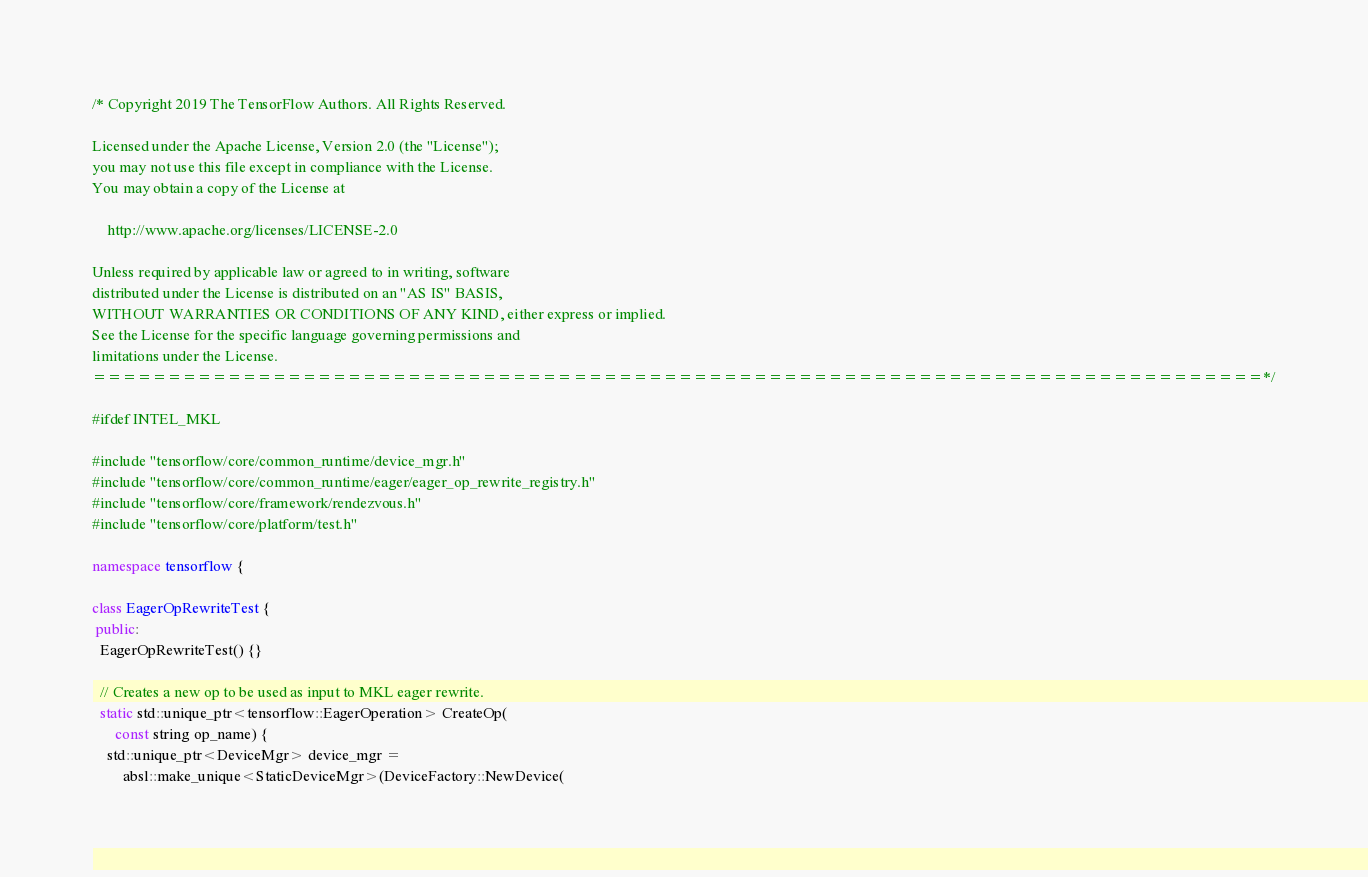Convert code to text. <code><loc_0><loc_0><loc_500><loc_500><_C++_>/* Copyright 2019 The TensorFlow Authors. All Rights Reserved.

Licensed under the Apache License, Version 2.0 (the "License");
you may not use this file except in compliance with the License.
You may obtain a copy of the License at

    http://www.apache.org/licenses/LICENSE-2.0

Unless required by applicable law or agreed to in writing, software
distributed under the License is distributed on an "AS IS" BASIS,
WITHOUT WARRANTIES OR CONDITIONS OF ANY KIND, either express or implied.
See the License for the specific language governing permissions and
limitations under the License.
==============================================================================*/

#ifdef INTEL_MKL

#include "tensorflow/core/common_runtime/device_mgr.h"
#include "tensorflow/core/common_runtime/eager/eager_op_rewrite_registry.h"
#include "tensorflow/core/framework/rendezvous.h"
#include "tensorflow/core/platform/test.h"

namespace tensorflow {

class EagerOpRewriteTest {
 public:
  EagerOpRewriteTest() {}

  // Creates a new op to be used as input to MKL eager rewrite.
  static std::unique_ptr<tensorflow::EagerOperation> CreateOp(
      const string op_name) {
    std::unique_ptr<DeviceMgr> device_mgr =
        absl::make_unique<StaticDeviceMgr>(DeviceFactory::NewDevice(</code> 